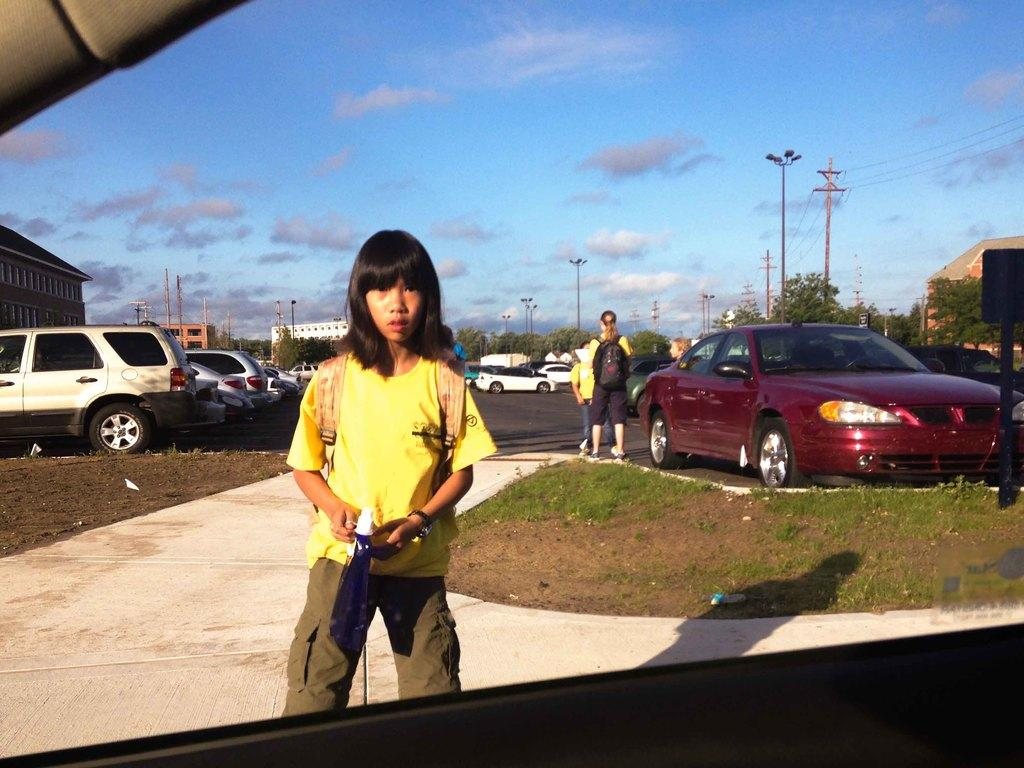What can be seen in the image? There are people standing, buildings, trees, current poles, street lights, a pathway, and vehicles parked in the image. Can you describe the surroundings in the image? The surroundings include trees, buildings, and a pathway. What is visible in the background of the image? The sky is visible in the background of the image. How are the vehicles positioned in the image? The vehicles are parked in the image. How many flags are present in the image? There are no flags visible in the image. What color is the scarf worn by the person in the image? There are no people wearing scarves in the image. 